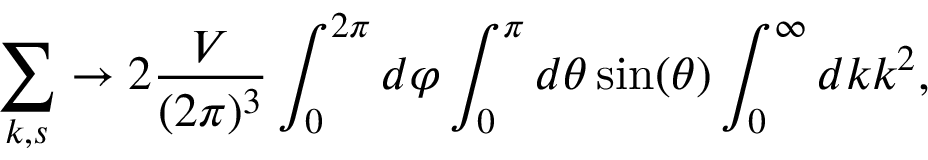<formula> <loc_0><loc_0><loc_500><loc_500>\sum _ { { k } , s } \to 2 \frac { V } { ( 2 \pi ) ^ { 3 } } \int _ { 0 } ^ { 2 \pi } d \varphi \int _ { 0 } ^ { \pi } d \theta \sin ( \theta ) \int _ { 0 } ^ { \infty } d k k ^ { 2 } ,</formula> 